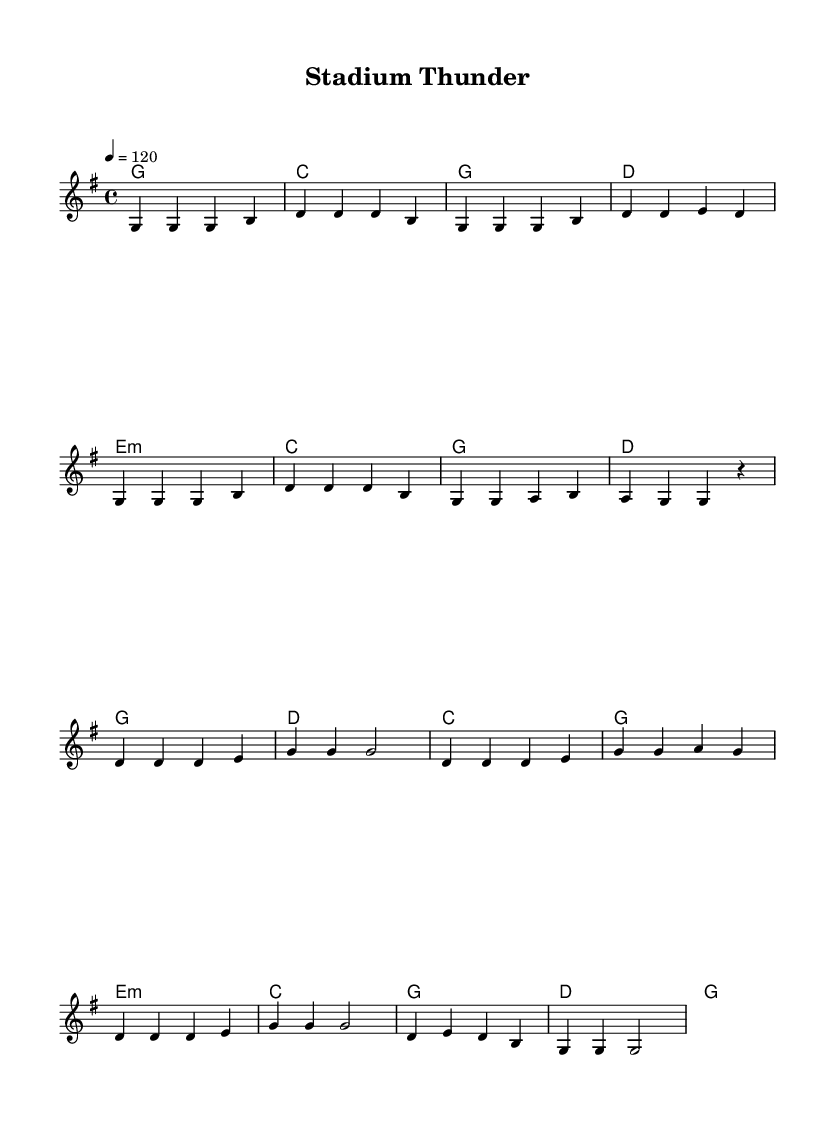What is the key signature of this music? The key signature shows one sharp, which indicates it is in G major. G major has an F# as its only sharp.
Answer: G major What is the time signature of this music? The time signature is noted at the beginning with a "4/4" notation, indicating that there are four beats per measure and a quarter note gets one beat.
Answer: 4/4 What is the tempo marking for this piece? The tempo marking, indicated at the start, shows "4 = 120," meaning the quarter note is to be played at a speed of 120 beats per minute.
Answer: 120 How many measures are in the verse section? Counting the measures in the specified verse portion of the melody, there are 8 measures present.
Answer: 8 What is the first chord of the chorus? The first chord noted in the chorus section is G, which is represented by the "g1" in the chord progression.
Answer: G How many distinct chords are used in this piece? By analyzing the chord progression, there are 6 distinct chords used: G, C, D, E minor, A, and B.
Answer: 6 What is the last note of the melody? The last note of the melody is a G, indicated by the "g2" notation at the end of the score.
Answer: G 